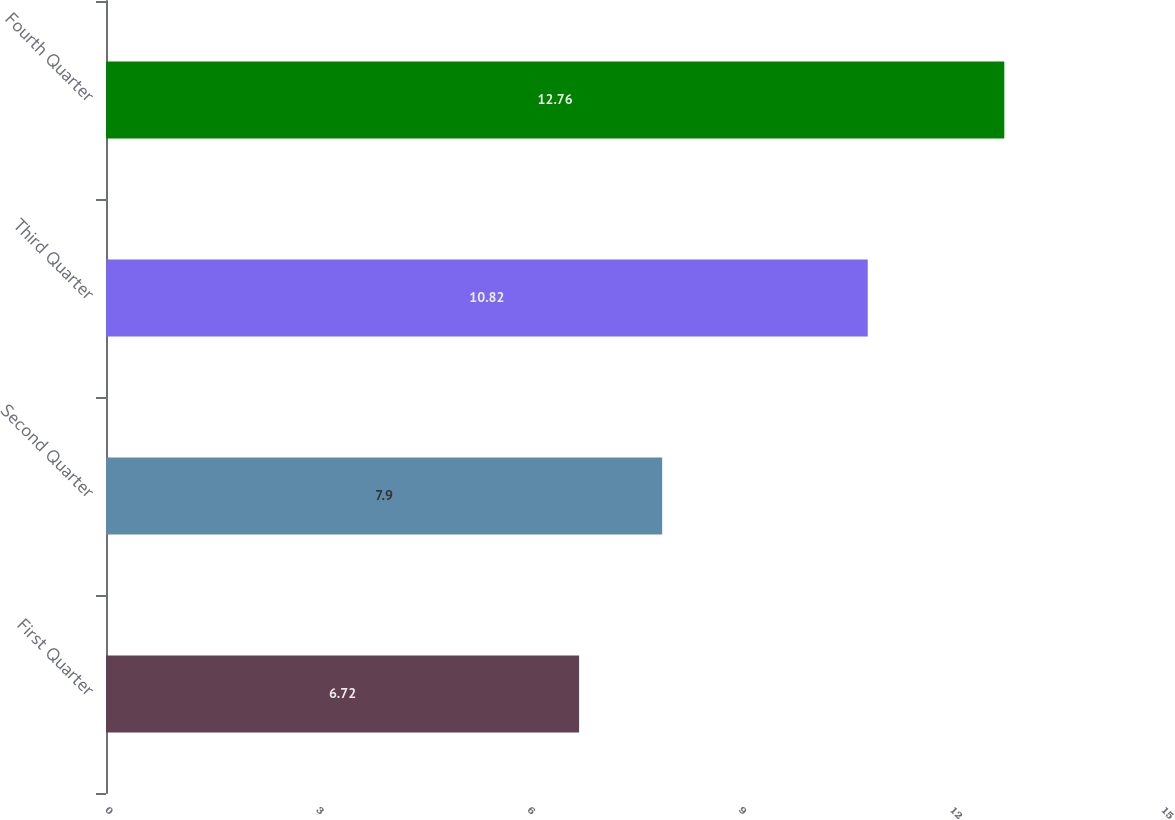Convert chart. <chart><loc_0><loc_0><loc_500><loc_500><bar_chart><fcel>First Quarter<fcel>Second Quarter<fcel>Third Quarter<fcel>Fourth Quarter<nl><fcel>6.72<fcel>7.9<fcel>10.82<fcel>12.76<nl></chart> 